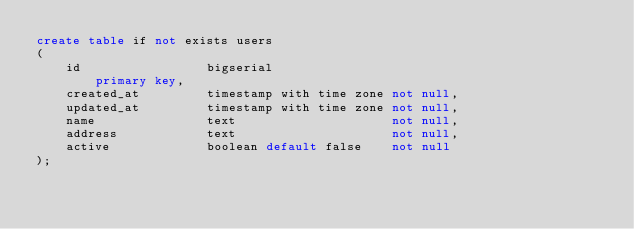<code> <loc_0><loc_0><loc_500><loc_500><_SQL_>create table if not exists users
(
    id                 bigserial
        primary key,
    created_at         timestamp with time zone not null,
    updated_at         timestamp with time zone not null,
    name               text                     not null,
    address            text                     not null,
    active             boolean default false    not null
);</code> 